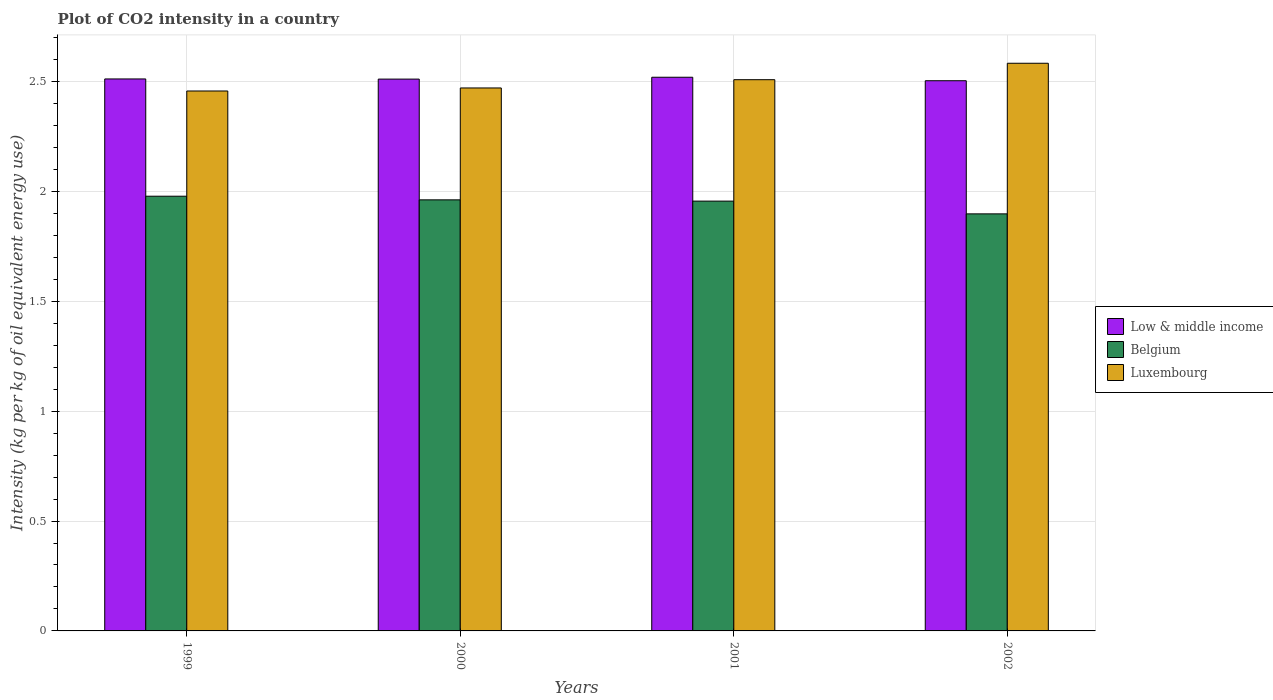How many bars are there on the 3rd tick from the right?
Provide a short and direct response. 3. What is the label of the 4th group of bars from the left?
Offer a terse response. 2002. In how many cases, is the number of bars for a given year not equal to the number of legend labels?
Your response must be concise. 0. What is the CO2 intensity in in Belgium in 2001?
Offer a terse response. 1.96. Across all years, what is the maximum CO2 intensity in in Low & middle income?
Make the answer very short. 2.52. Across all years, what is the minimum CO2 intensity in in Belgium?
Ensure brevity in your answer.  1.9. In which year was the CO2 intensity in in Low & middle income minimum?
Offer a very short reply. 2002. What is the total CO2 intensity in in Luxembourg in the graph?
Offer a terse response. 10.02. What is the difference between the CO2 intensity in in Belgium in 1999 and that in 2001?
Provide a short and direct response. 0.02. What is the difference between the CO2 intensity in in Low & middle income in 2001 and the CO2 intensity in in Luxembourg in 2002?
Your answer should be compact. -0.06. What is the average CO2 intensity in in Low & middle income per year?
Offer a terse response. 2.51. In the year 2001, what is the difference between the CO2 intensity in in Luxembourg and CO2 intensity in in Low & middle income?
Your answer should be very brief. -0.01. In how many years, is the CO2 intensity in in Belgium greater than 1.8 kg?
Your answer should be very brief. 4. What is the ratio of the CO2 intensity in in Low & middle income in 2001 to that in 2002?
Offer a terse response. 1.01. Is the CO2 intensity in in Luxembourg in 2000 less than that in 2002?
Provide a short and direct response. Yes. What is the difference between the highest and the second highest CO2 intensity in in Low & middle income?
Your response must be concise. 0.01. What is the difference between the highest and the lowest CO2 intensity in in Low & middle income?
Your answer should be very brief. 0.02. Is the sum of the CO2 intensity in in Luxembourg in 1999 and 2002 greater than the maximum CO2 intensity in in Low & middle income across all years?
Your answer should be very brief. Yes. How many bars are there?
Give a very brief answer. 12. What is the difference between two consecutive major ticks on the Y-axis?
Ensure brevity in your answer.  0.5. Are the values on the major ticks of Y-axis written in scientific E-notation?
Make the answer very short. No. Where does the legend appear in the graph?
Provide a short and direct response. Center right. How many legend labels are there?
Your response must be concise. 3. How are the legend labels stacked?
Keep it short and to the point. Vertical. What is the title of the graph?
Offer a very short reply. Plot of CO2 intensity in a country. What is the label or title of the Y-axis?
Make the answer very short. Intensity (kg per kg of oil equivalent energy use). What is the Intensity (kg per kg of oil equivalent energy use) in Low & middle income in 1999?
Your response must be concise. 2.51. What is the Intensity (kg per kg of oil equivalent energy use) in Belgium in 1999?
Offer a very short reply. 1.98. What is the Intensity (kg per kg of oil equivalent energy use) of Luxembourg in 1999?
Provide a short and direct response. 2.46. What is the Intensity (kg per kg of oil equivalent energy use) in Low & middle income in 2000?
Offer a very short reply. 2.51. What is the Intensity (kg per kg of oil equivalent energy use) in Belgium in 2000?
Your answer should be compact. 1.96. What is the Intensity (kg per kg of oil equivalent energy use) in Luxembourg in 2000?
Provide a succinct answer. 2.47. What is the Intensity (kg per kg of oil equivalent energy use) in Low & middle income in 2001?
Your answer should be very brief. 2.52. What is the Intensity (kg per kg of oil equivalent energy use) of Belgium in 2001?
Provide a short and direct response. 1.96. What is the Intensity (kg per kg of oil equivalent energy use) in Luxembourg in 2001?
Keep it short and to the point. 2.51. What is the Intensity (kg per kg of oil equivalent energy use) of Low & middle income in 2002?
Give a very brief answer. 2.5. What is the Intensity (kg per kg of oil equivalent energy use) in Belgium in 2002?
Provide a succinct answer. 1.9. What is the Intensity (kg per kg of oil equivalent energy use) of Luxembourg in 2002?
Your answer should be very brief. 2.58. Across all years, what is the maximum Intensity (kg per kg of oil equivalent energy use) in Low & middle income?
Provide a succinct answer. 2.52. Across all years, what is the maximum Intensity (kg per kg of oil equivalent energy use) of Belgium?
Your answer should be compact. 1.98. Across all years, what is the maximum Intensity (kg per kg of oil equivalent energy use) in Luxembourg?
Ensure brevity in your answer.  2.58. Across all years, what is the minimum Intensity (kg per kg of oil equivalent energy use) in Low & middle income?
Your response must be concise. 2.5. Across all years, what is the minimum Intensity (kg per kg of oil equivalent energy use) in Belgium?
Make the answer very short. 1.9. Across all years, what is the minimum Intensity (kg per kg of oil equivalent energy use) of Luxembourg?
Your answer should be very brief. 2.46. What is the total Intensity (kg per kg of oil equivalent energy use) in Low & middle income in the graph?
Your response must be concise. 10.05. What is the total Intensity (kg per kg of oil equivalent energy use) in Belgium in the graph?
Offer a very short reply. 7.79. What is the total Intensity (kg per kg of oil equivalent energy use) of Luxembourg in the graph?
Give a very brief answer. 10.02. What is the difference between the Intensity (kg per kg of oil equivalent energy use) of Low & middle income in 1999 and that in 2000?
Keep it short and to the point. 0. What is the difference between the Intensity (kg per kg of oil equivalent energy use) of Belgium in 1999 and that in 2000?
Make the answer very short. 0.02. What is the difference between the Intensity (kg per kg of oil equivalent energy use) in Luxembourg in 1999 and that in 2000?
Give a very brief answer. -0.01. What is the difference between the Intensity (kg per kg of oil equivalent energy use) of Low & middle income in 1999 and that in 2001?
Give a very brief answer. -0.01. What is the difference between the Intensity (kg per kg of oil equivalent energy use) of Belgium in 1999 and that in 2001?
Your answer should be compact. 0.02. What is the difference between the Intensity (kg per kg of oil equivalent energy use) in Luxembourg in 1999 and that in 2001?
Your answer should be compact. -0.05. What is the difference between the Intensity (kg per kg of oil equivalent energy use) of Low & middle income in 1999 and that in 2002?
Ensure brevity in your answer.  0.01. What is the difference between the Intensity (kg per kg of oil equivalent energy use) of Belgium in 1999 and that in 2002?
Provide a short and direct response. 0.08. What is the difference between the Intensity (kg per kg of oil equivalent energy use) of Luxembourg in 1999 and that in 2002?
Offer a very short reply. -0.13. What is the difference between the Intensity (kg per kg of oil equivalent energy use) in Low & middle income in 2000 and that in 2001?
Offer a very short reply. -0.01. What is the difference between the Intensity (kg per kg of oil equivalent energy use) in Belgium in 2000 and that in 2001?
Your answer should be very brief. 0.01. What is the difference between the Intensity (kg per kg of oil equivalent energy use) of Luxembourg in 2000 and that in 2001?
Provide a succinct answer. -0.04. What is the difference between the Intensity (kg per kg of oil equivalent energy use) in Low & middle income in 2000 and that in 2002?
Keep it short and to the point. 0.01. What is the difference between the Intensity (kg per kg of oil equivalent energy use) of Belgium in 2000 and that in 2002?
Offer a terse response. 0.06. What is the difference between the Intensity (kg per kg of oil equivalent energy use) of Luxembourg in 2000 and that in 2002?
Make the answer very short. -0.11. What is the difference between the Intensity (kg per kg of oil equivalent energy use) of Low & middle income in 2001 and that in 2002?
Ensure brevity in your answer.  0.02. What is the difference between the Intensity (kg per kg of oil equivalent energy use) of Belgium in 2001 and that in 2002?
Your response must be concise. 0.06. What is the difference between the Intensity (kg per kg of oil equivalent energy use) of Luxembourg in 2001 and that in 2002?
Make the answer very short. -0.07. What is the difference between the Intensity (kg per kg of oil equivalent energy use) of Low & middle income in 1999 and the Intensity (kg per kg of oil equivalent energy use) of Belgium in 2000?
Provide a short and direct response. 0.55. What is the difference between the Intensity (kg per kg of oil equivalent energy use) in Low & middle income in 1999 and the Intensity (kg per kg of oil equivalent energy use) in Luxembourg in 2000?
Keep it short and to the point. 0.04. What is the difference between the Intensity (kg per kg of oil equivalent energy use) in Belgium in 1999 and the Intensity (kg per kg of oil equivalent energy use) in Luxembourg in 2000?
Provide a succinct answer. -0.49. What is the difference between the Intensity (kg per kg of oil equivalent energy use) of Low & middle income in 1999 and the Intensity (kg per kg of oil equivalent energy use) of Belgium in 2001?
Offer a terse response. 0.56. What is the difference between the Intensity (kg per kg of oil equivalent energy use) of Low & middle income in 1999 and the Intensity (kg per kg of oil equivalent energy use) of Luxembourg in 2001?
Offer a terse response. 0. What is the difference between the Intensity (kg per kg of oil equivalent energy use) of Belgium in 1999 and the Intensity (kg per kg of oil equivalent energy use) of Luxembourg in 2001?
Provide a succinct answer. -0.53. What is the difference between the Intensity (kg per kg of oil equivalent energy use) of Low & middle income in 1999 and the Intensity (kg per kg of oil equivalent energy use) of Belgium in 2002?
Offer a terse response. 0.61. What is the difference between the Intensity (kg per kg of oil equivalent energy use) of Low & middle income in 1999 and the Intensity (kg per kg of oil equivalent energy use) of Luxembourg in 2002?
Keep it short and to the point. -0.07. What is the difference between the Intensity (kg per kg of oil equivalent energy use) in Belgium in 1999 and the Intensity (kg per kg of oil equivalent energy use) in Luxembourg in 2002?
Offer a terse response. -0.6. What is the difference between the Intensity (kg per kg of oil equivalent energy use) in Low & middle income in 2000 and the Intensity (kg per kg of oil equivalent energy use) in Belgium in 2001?
Offer a very short reply. 0.56. What is the difference between the Intensity (kg per kg of oil equivalent energy use) in Low & middle income in 2000 and the Intensity (kg per kg of oil equivalent energy use) in Luxembourg in 2001?
Your answer should be very brief. 0. What is the difference between the Intensity (kg per kg of oil equivalent energy use) of Belgium in 2000 and the Intensity (kg per kg of oil equivalent energy use) of Luxembourg in 2001?
Offer a very short reply. -0.55. What is the difference between the Intensity (kg per kg of oil equivalent energy use) in Low & middle income in 2000 and the Intensity (kg per kg of oil equivalent energy use) in Belgium in 2002?
Make the answer very short. 0.61. What is the difference between the Intensity (kg per kg of oil equivalent energy use) of Low & middle income in 2000 and the Intensity (kg per kg of oil equivalent energy use) of Luxembourg in 2002?
Keep it short and to the point. -0.07. What is the difference between the Intensity (kg per kg of oil equivalent energy use) of Belgium in 2000 and the Intensity (kg per kg of oil equivalent energy use) of Luxembourg in 2002?
Your response must be concise. -0.62. What is the difference between the Intensity (kg per kg of oil equivalent energy use) of Low & middle income in 2001 and the Intensity (kg per kg of oil equivalent energy use) of Belgium in 2002?
Make the answer very short. 0.62. What is the difference between the Intensity (kg per kg of oil equivalent energy use) in Low & middle income in 2001 and the Intensity (kg per kg of oil equivalent energy use) in Luxembourg in 2002?
Make the answer very short. -0.06. What is the difference between the Intensity (kg per kg of oil equivalent energy use) of Belgium in 2001 and the Intensity (kg per kg of oil equivalent energy use) of Luxembourg in 2002?
Your answer should be compact. -0.63. What is the average Intensity (kg per kg of oil equivalent energy use) of Low & middle income per year?
Offer a terse response. 2.51. What is the average Intensity (kg per kg of oil equivalent energy use) in Belgium per year?
Offer a very short reply. 1.95. What is the average Intensity (kg per kg of oil equivalent energy use) of Luxembourg per year?
Your answer should be very brief. 2.5. In the year 1999, what is the difference between the Intensity (kg per kg of oil equivalent energy use) of Low & middle income and Intensity (kg per kg of oil equivalent energy use) of Belgium?
Offer a terse response. 0.53. In the year 1999, what is the difference between the Intensity (kg per kg of oil equivalent energy use) in Low & middle income and Intensity (kg per kg of oil equivalent energy use) in Luxembourg?
Make the answer very short. 0.05. In the year 1999, what is the difference between the Intensity (kg per kg of oil equivalent energy use) of Belgium and Intensity (kg per kg of oil equivalent energy use) of Luxembourg?
Provide a short and direct response. -0.48. In the year 2000, what is the difference between the Intensity (kg per kg of oil equivalent energy use) in Low & middle income and Intensity (kg per kg of oil equivalent energy use) in Belgium?
Make the answer very short. 0.55. In the year 2000, what is the difference between the Intensity (kg per kg of oil equivalent energy use) in Low & middle income and Intensity (kg per kg of oil equivalent energy use) in Luxembourg?
Offer a terse response. 0.04. In the year 2000, what is the difference between the Intensity (kg per kg of oil equivalent energy use) in Belgium and Intensity (kg per kg of oil equivalent energy use) in Luxembourg?
Provide a succinct answer. -0.51. In the year 2001, what is the difference between the Intensity (kg per kg of oil equivalent energy use) of Low & middle income and Intensity (kg per kg of oil equivalent energy use) of Belgium?
Your answer should be very brief. 0.56. In the year 2001, what is the difference between the Intensity (kg per kg of oil equivalent energy use) of Low & middle income and Intensity (kg per kg of oil equivalent energy use) of Luxembourg?
Your response must be concise. 0.01. In the year 2001, what is the difference between the Intensity (kg per kg of oil equivalent energy use) in Belgium and Intensity (kg per kg of oil equivalent energy use) in Luxembourg?
Provide a succinct answer. -0.55. In the year 2002, what is the difference between the Intensity (kg per kg of oil equivalent energy use) in Low & middle income and Intensity (kg per kg of oil equivalent energy use) in Belgium?
Offer a very short reply. 0.61. In the year 2002, what is the difference between the Intensity (kg per kg of oil equivalent energy use) in Low & middle income and Intensity (kg per kg of oil equivalent energy use) in Luxembourg?
Your answer should be compact. -0.08. In the year 2002, what is the difference between the Intensity (kg per kg of oil equivalent energy use) in Belgium and Intensity (kg per kg of oil equivalent energy use) in Luxembourg?
Give a very brief answer. -0.69. What is the ratio of the Intensity (kg per kg of oil equivalent energy use) in Low & middle income in 1999 to that in 2000?
Ensure brevity in your answer.  1. What is the ratio of the Intensity (kg per kg of oil equivalent energy use) in Belgium in 1999 to that in 2000?
Your answer should be very brief. 1.01. What is the ratio of the Intensity (kg per kg of oil equivalent energy use) in Luxembourg in 1999 to that in 2000?
Offer a terse response. 0.99. What is the ratio of the Intensity (kg per kg of oil equivalent energy use) of Belgium in 1999 to that in 2001?
Offer a terse response. 1.01. What is the ratio of the Intensity (kg per kg of oil equivalent energy use) in Luxembourg in 1999 to that in 2001?
Make the answer very short. 0.98. What is the ratio of the Intensity (kg per kg of oil equivalent energy use) of Low & middle income in 1999 to that in 2002?
Your response must be concise. 1. What is the ratio of the Intensity (kg per kg of oil equivalent energy use) of Belgium in 1999 to that in 2002?
Provide a succinct answer. 1.04. What is the ratio of the Intensity (kg per kg of oil equivalent energy use) in Luxembourg in 1999 to that in 2002?
Provide a succinct answer. 0.95. What is the ratio of the Intensity (kg per kg of oil equivalent energy use) of Belgium in 2000 to that in 2001?
Your answer should be compact. 1. What is the ratio of the Intensity (kg per kg of oil equivalent energy use) in Low & middle income in 2000 to that in 2002?
Keep it short and to the point. 1. What is the ratio of the Intensity (kg per kg of oil equivalent energy use) in Belgium in 2000 to that in 2002?
Ensure brevity in your answer.  1.03. What is the ratio of the Intensity (kg per kg of oil equivalent energy use) in Luxembourg in 2000 to that in 2002?
Offer a very short reply. 0.96. What is the ratio of the Intensity (kg per kg of oil equivalent energy use) in Belgium in 2001 to that in 2002?
Provide a short and direct response. 1.03. What is the difference between the highest and the second highest Intensity (kg per kg of oil equivalent energy use) of Low & middle income?
Give a very brief answer. 0.01. What is the difference between the highest and the second highest Intensity (kg per kg of oil equivalent energy use) in Belgium?
Provide a succinct answer. 0.02. What is the difference between the highest and the second highest Intensity (kg per kg of oil equivalent energy use) of Luxembourg?
Provide a succinct answer. 0.07. What is the difference between the highest and the lowest Intensity (kg per kg of oil equivalent energy use) in Low & middle income?
Ensure brevity in your answer.  0.02. What is the difference between the highest and the lowest Intensity (kg per kg of oil equivalent energy use) of Belgium?
Your answer should be compact. 0.08. What is the difference between the highest and the lowest Intensity (kg per kg of oil equivalent energy use) of Luxembourg?
Ensure brevity in your answer.  0.13. 